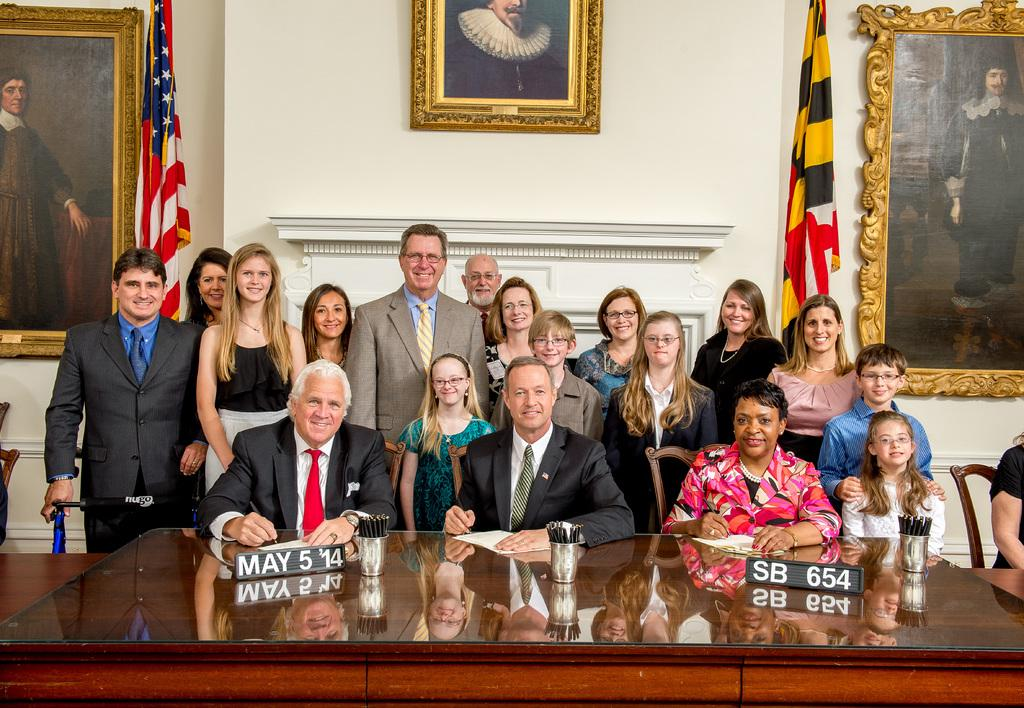How many people are in the image? There is a group of people in the image. What are the people in the image doing? Some of the people are standing, while others are seated on chairs. What is the purpose of the table in the image? The table's purpose is not specified, but it is likely being used for some activity or as a surface for objects. What is the photo frame used for in the image? The photo frame is likely being used to display a photograph or artwork. What are the two flags representing in the image? The flags' meanings are not specified, but they may represent countries, organizations, or events. How many dogs are learning to walk on their hind legs in the image? There are no dogs present in the image, and therefore no such activity can be observed. 